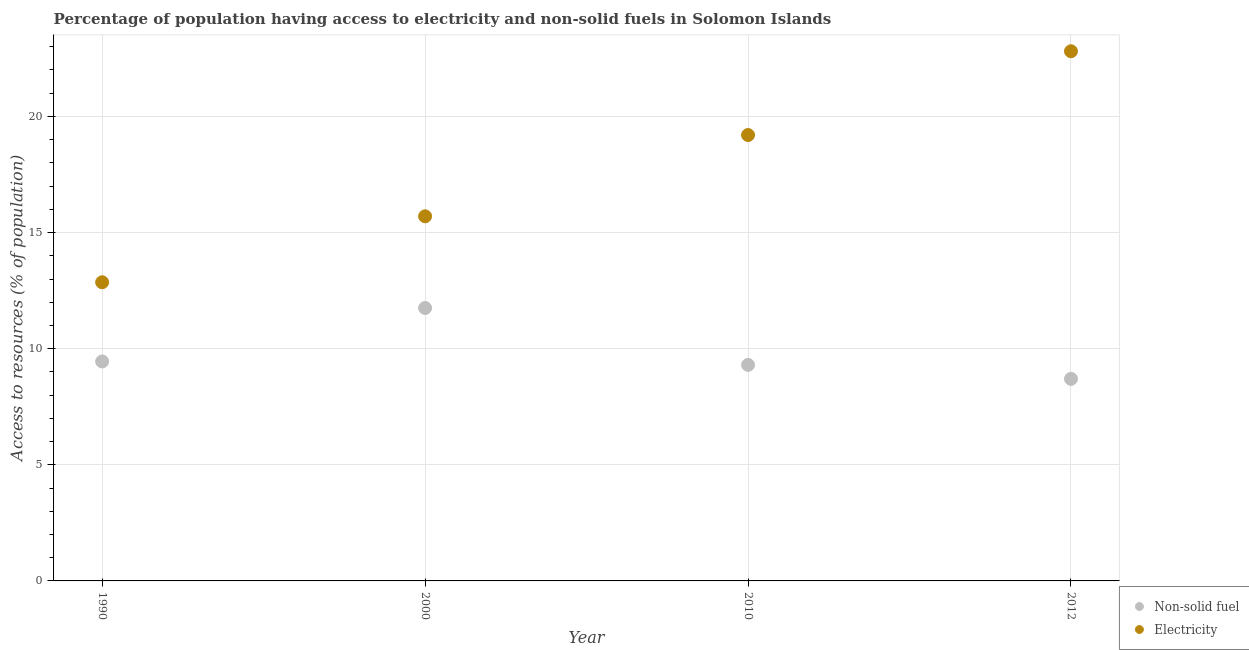How many different coloured dotlines are there?
Offer a very short reply. 2. Is the number of dotlines equal to the number of legend labels?
Provide a succinct answer. Yes. What is the percentage of population having access to electricity in 2010?
Keep it short and to the point. 19.2. Across all years, what is the maximum percentage of population having access to electricity?
Offer a very short reply. 22.81. Across all years, what is the minimum percentage of population having access to electricity?
Keep it short and to the point. 12.86. In which year was the percentage of population having access to electricity minimum?
Your answer should be very brief. 1990. What is the total percentage of population having access to non-solid fuel in the graph?
Provide a short and direct response. 39.2. What is the difference between the percentage of population having access to electricity in 1990 and that in 2000?
Offer a terse response. -2.84. What is the difference between the percentage of population having access to non-solid fuel in 1990 and the percentage of population having access to electricity in 2000?
Make the answer very short. -6.25. What is the average percentage of population having access to electricity per year?
Offer a very short reply. 17.64. In the year 2010, what is the difference between the percentage of population having access to electricity and percentage of population having access to non-solid fuel?
Offer a terse response. 9.9. In how many years, is the percentage of population having access to non-solid fuel greater than 3 %?
Offer a terse response. 4. What is the ratio of the percentage of population having access to non-solid fuel in 2000 to that in 2012?
Give a very brief answer. 1.35. Is the percentage of population having access to electricity in 2010 less than that in 2012?
Make the answer very short. Yes. What is the difference between the highest and the second highest percentage of population having access to non-solid fuel?
Offer a very short reply. 2.3. What is the difference between the highest and the lowest percentage of population having access to electricity?
Offer a very short reply. 9.95. In how many years, is the percentage of population having access to electricity greater than the average percentage of population having access to electricity taken over all years?
Make the answer very short. 2. Does the percentage of population having access to electricity monotonically increase over the years?
Keep it short and to the point. Yes. Is the percentage of population having access to non-solid fuel strictly greater than the percentage of population having access to electricity over the years?
Your answer should be compact. No. How many dotlines are there?
Ensure brevity in your answer.  2. How many years are there in the graph?
Make the answer very short. 4. Does the graph contain any zero values?
Ensure brevity in your answer.  No. Does the graph contain grids?
Provide a short and direct response. Yes. How many legend labels are there?
Keep it short and to the point. 2. How are the legend labels stacked?
Your response must be concise. Vertical. What is the title of the graph?
Offer a terse response. Percentage of population having access to electricity and non-solid fuels in Solomon Islands. Does "Total Population" appear as one of the legend labels in the graph?
Your answer should be compact. No. What is the label or title of the Y-axis?
Provide a short and direct response. Access to resources (% of population). What is the Access to resources (% of population) of Non-solid fuel in 1990?
Ensure brevity in your answer.  9.45. What is the Access to resources (% of population) of Electricity in 1990?
Provide a succinct answer. 12.86. What is the Access to resources (% of population) in Non-solid fuel in 2000?
Offer a terse response. 11.75. What is the Access to resources (% of population) in Non-solid fuel in 2010?
Ensure brevity in your answer.  9.3. What is the Access to resources (% of population) in Electricity in 2010?
Give a very brief answer. 19.2. What is the Access to resources (% of population) of Non-solid fuel in 2012?
Your answer should be compact. 8.7. What is the Access to resources (% of population) in Electricity in 2012?
Ensure brevity in your answer.  22.81. Across all years, what is the maximum Access to resources (% of population) in Non-solid fuel?
Give a very brief answer. 11.75. Across all years, what is the maximum Access to resources (% of population) of Electricity?
Your response must be concise. 22.81. Across all years, what is the minimum Access to resources (% of population) in Non-solid fuel?
Ensure brevity in your answer.  8.7. Across all years, what is the minimum Access to resources (% of population) of Electricity?
Offer a very short reply. 12.86. What is the total Access to resources (% of population) of Non-solid fuel in the graph?
Make the answer very short. 39.2. What is the total Access to resources (% of population) of Electricity in the graph?
Make the answer very short. 70.57. What is the difference between the Access to resources (% of population) in Non-solid fuel in 1990 and that in 2000?
Your answer should be very brief. -2.3. What is the difference between the Access to resources (% of population) of Electricity in 1990 and that in 2000?
Offer a very short reply. -2.84. What is the difference between the Access to resources (% of population) of Non-solid fuel in 1990 and that in 2010?
Ensure brevity in your answer.  0.15. What is the difference between the Access to resources (% of population) in Electricity in 1990 and that in 2010?
Keep it short and to the point. -6.34. What is the difference between the Access to resources (% of population) of Non-solid fuel in 1990 and that in 2012?
Keep it short and to the point. 0.75. What is the difference between the Access to resources (% of population) in Electricity in 1990 and that in 2012?
Make the answer very short. -9.95. What is the difference between the Access to resources (% of population) in Non-solid fuel in 2000 and that in 2010?
Ensure brevity in your answer.  2.45. What is the difference between the Access to resources (% of population) of Electricity in 2000 and that in 2010?
Your answer should be very brief. -3.5. What is the difference between the Access to resources (% of population) of Non-solid fuel in 2000 and that in 2012?
Your answer should be very brief. 3.05. What is the difference between the Access to resources (% of population) of Electricity in 2000 and that in 2012?
Make the answer very short. -7.11. What is the difference between the Access to resources (% of population) in Non-solid fuel in 2010 and that in 2012?
Give a very brief answer. 0.6. What is the difference between the Access to resources (% of population) in Electricity in 2010 and that in 2012?
Offer a terse response. -3.61. What is the difference between the Access to resources (% of population) in Non-solid fuel in 1990 and the Access to resources (% of population) in Electricity in 2000?
Keep it short and to the point. -6.25. What is the difference between the Access to resources (% of population) in Non-solid fuel in 1990 and the Access to resources (% of population) in Electricity in 2010?
Your answer should be very brief. -9.75. What is the difference between the Access to resources (% of population) in Non-solid fuel in 1990 and the Access to resources (% of population) in Electricity in 2012?
Your answer should be compact. -13.36. What is the difference between the Access to resources (% of population) of Non-solid fuel in 2000 and the Access to resources (% of population) of Electricity in 2010?
Keep it short and to the point. -7.45. What is the difference between the Access to resources (% of population) in Non-solid fuel in 2000 and the Access to resources (% of population) in Electricity in 2012?
Keep it short and to the point. -11.05. What is the difference between the Access to resources (% of population) in Non-solid fuel in 2010 and the Access to resources (% of population) in Electricity in 2012?
Your response must be concise. -13.5. What is the average Access to resources (% of population) of Non-solid fuel per year?
Keep it short and to the point. 9.8. What is the average Access to resources (% of population) in Electricity per year?
Your answer should be very brief. 17.64. In the year 1990, what is the difference between the Access to resources (% of population) in Non-solid fuel and Access to resources (% of population) in Electricity?
Ensure brevity in your answer.  -3.41. In the year 2000, what is the difference between the Access to resources (% of population) in Non-solid fuel and Access to resources (% of population) in Electricity?
Offer a terse response. -3.95. In the year 2010, what is the difference between the Access to resources (% of population) in Non-solid fuel and Access to resources (% of population) in Electricity?
Ensure brevity in your answer.  -9.9. In the year 2012, what is the difference between the Access to resources (% of population) in Non-solid fuel and Access to resources (% of population) in Electricity?
Give a very brief answer. -14.11. What is the ratio of the Access to resources (% of population) in Non-solid fuel in 1990 to that in 2000?
Make the answer very short. 0.8. What is the ratio of the Access to resources (% of population) in Electricity in 1990 to that in 2000?
Offer a terse response. 0.82. What is the ratio of the Access to resources (% of population) of Non-solid fuel in 1990 to that in 2010?
Ensure brevity in your answer.  1.02. What is the ratio of the Access to resources (% of population) of Electricity in 1990 to that in 2010?
Offer a terse response. 0.67. What is the ratio of the Access to resources (% of population) of Non-solid fuel in 1990 to that in 2012?
Provide a short and direct response. 1.09. What is the ratio of the Access to resources (% of population) of Electricity in 1990 to that in 2012?
Offer a very short reply. 0.56. What is the ratio of the Access to resources (% of population) in Non-solid fuel in 2000 to that in 2010?
Your response must be concise. 1.26. What is the ratio of the Access to resources (% of population) in Electricity in 2000 to that in 2010?
Ensure brevity in your answer.  0.82. What is the ratio of the Access to resources (% of population) in Non-solid fuel in 2000 to that in 2012?
Ensure brevity in your answer.  1.35. What is the ratio of the Access to resources (% of population) of Electricity in 2000 to that in 2012?
Give a very brief answer. 0.69. What is the ratio of the Access to resources (% of population) in Non-solid fuel in 2010 to that in 2012?
Provide a succinct answer. 1.07. What is the ratio of the Access to resources (% of population) of Electricity in 2010 to that in 2012?
Provide a succinct answer. 0.84. What is the difference between the highest and the second highest Access to resources (% of population) of Non-solid fuel?
Offer a very short reply. 2.3. What is the difference between the highest and the second highest Access to resources (% of population) in Electricity?
Your response must be concise. 3.61. What is the difference between the highest and the lowest Access to resources (% of population) in Non-solid fuel?
Provide a short and direct response. 3.05. What is the difference between the highest and the lowest Access to resources (% of population) of Electricity?
Give a very brief answer. 9.95. 